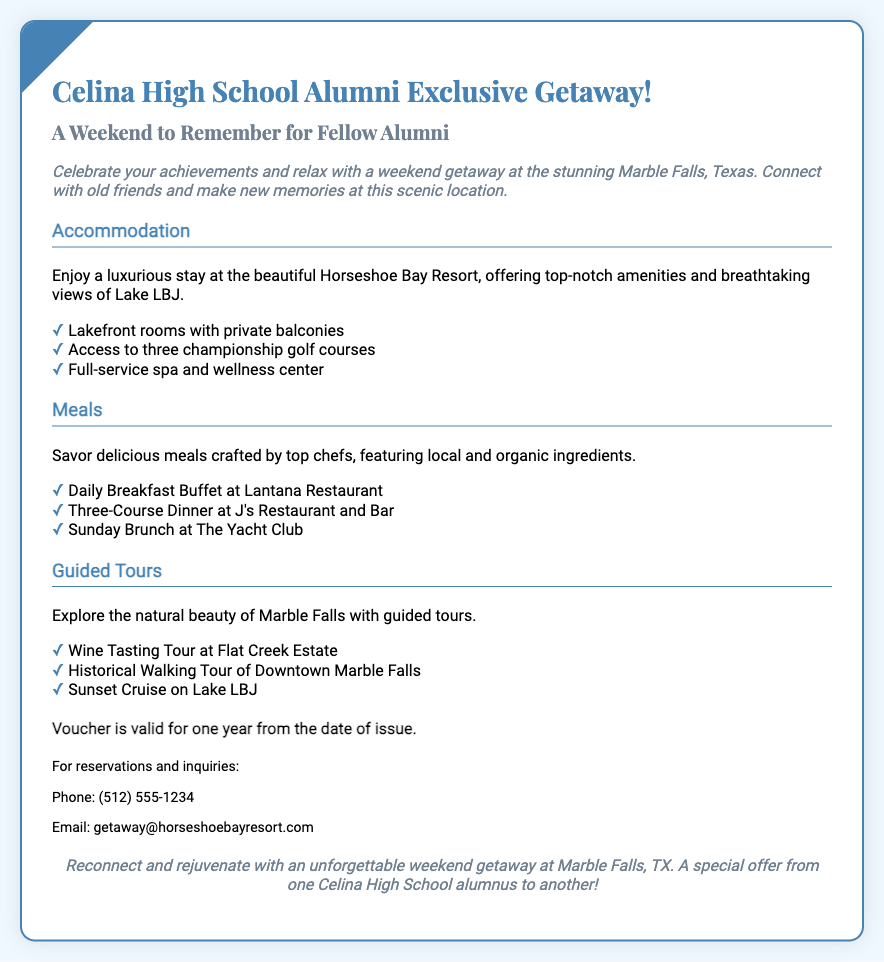What is the name of the resort? The resort mentioned in the document is called Horseshoe Bay Resort.
Answer: Horseshoe Bay Resort What is included in the meals? The meals include a daily breakfast buffet, a three-course dinner, and a Sunday brunch.
Answer: Daily Breakfast Buffet, Three-Course Dinner, Sunday Brunch How long is the voucher valid? The document states that the voucher is valid for one year from the date of issue.
Answer: One year What is the starting location for the getaway? The getaway is situated in Marble Falls, Texas, as noted in the description.
Answer: Marble Falls, Texas What type of tours are offered? The guided tours include a wine tasting tour, a historical walking tour, and a sunset cruise.
Answer: Wine Tasting Tour, Historical Walking Tour, Sunset Cruise What is a special feature of the accommodation? The document highlights lakefront rooms with private balconies as a special feature of the accommodation.
Answer: Lakefront rooms with private balconies What can guests access at the resort? Guests have access to three championship golf courses as stated in the accommodation section.
Answer: Three championship golf courses What contact methods are provided for inquiries? The document provides a phone number and an email for reservations and inquiries.
Answer: Phone and Email 